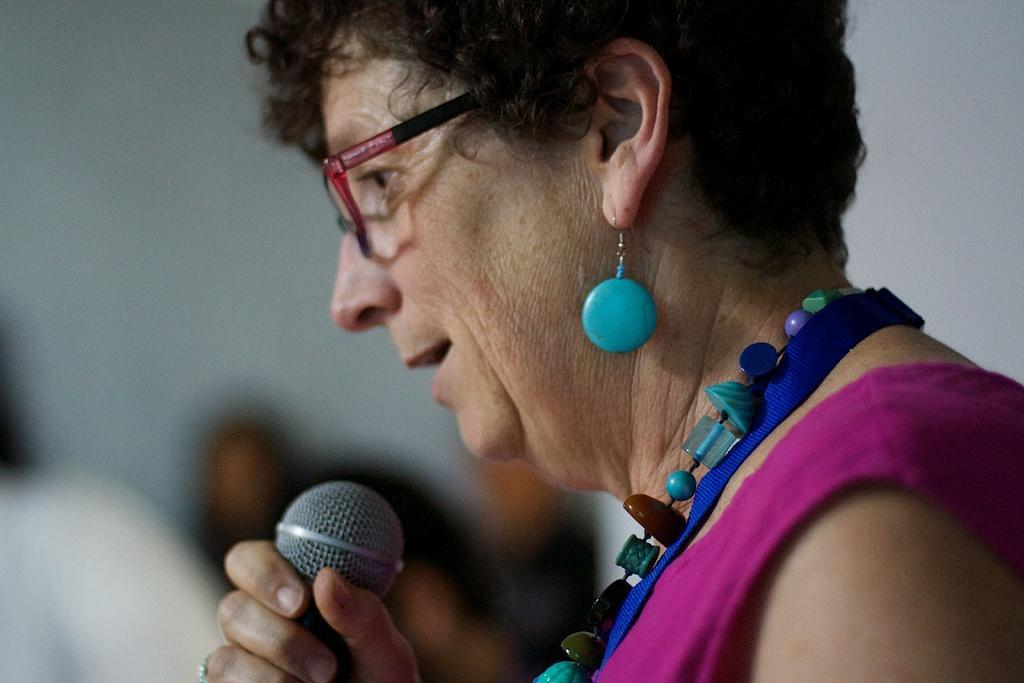Could you give a brief overview of what you see in this image? In this image I can see a person standing holding a microphone. The person is wearing pink dress and the person is also wearing colorful jewellery. 